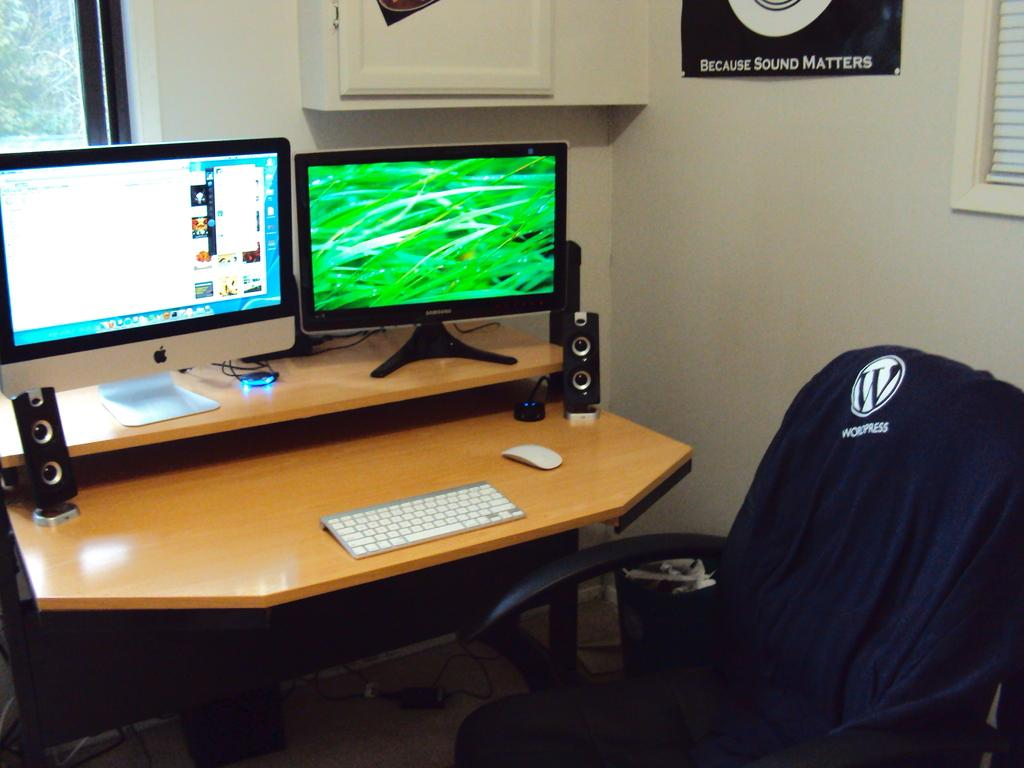What type of furniture is in the image? There is a table in the image. What electronic devices are on the table? Two monitors, a keyboard, a mouse, and speakers are on the table. What type of coach is sitting next to the table in the image? There is no coach present in the image; it only features a table and electronic devices. 